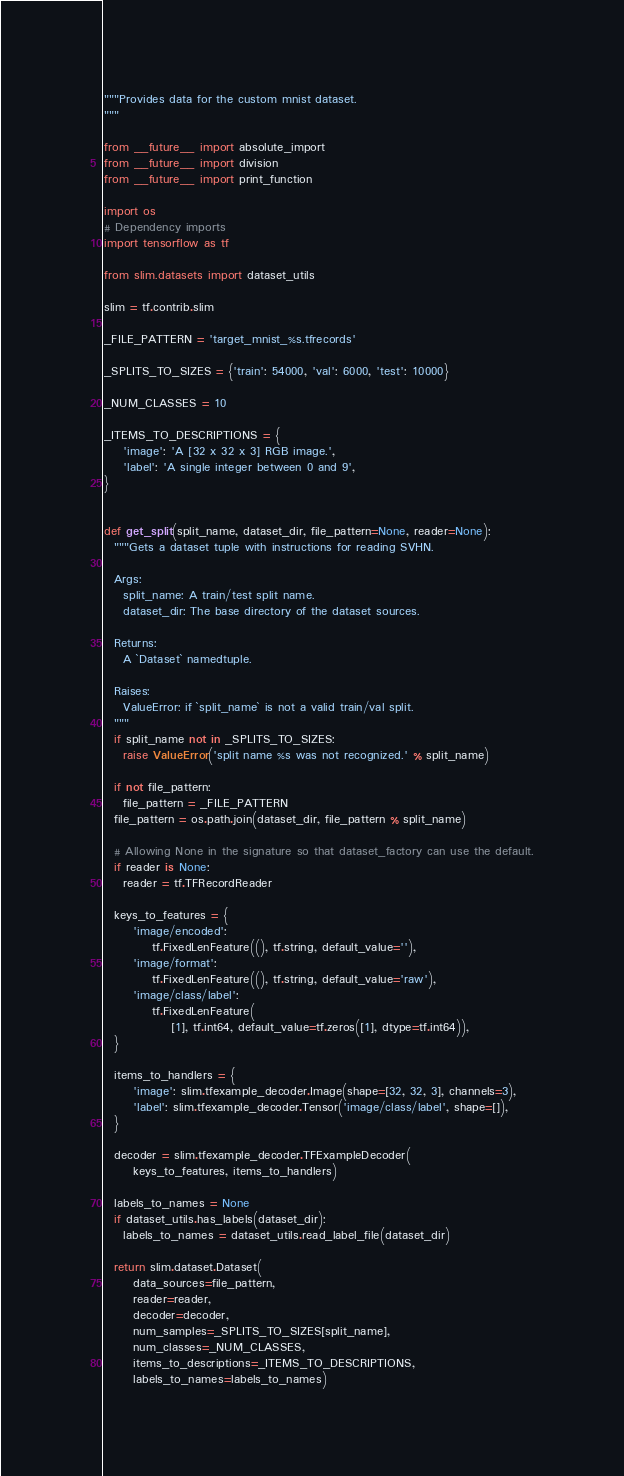Convert code to text. <code><loc_0><loc_0><loc_500><loc_500><_Python_>"""Provides data for the custom mnist dataset.
"""

from __future__ import absolute_import
from __future__ import division
from __future__ import print_function

import os
# Dependency imports
import tensorflow as tf

from slim.datasets import dataset_utils

slim = tf.contrib.slim

_FILE_PATTERN = 'target_mnist_%s.tfrecords'

_SPLITS_TO_SIZES = {'train': 54000, 'val': 6000, 'test': 10000}

_NUM_CLASSES = 10

_ITEMS_TO_DESCRIPTIONS = {
    'image': 'A [32 x 32 x 3] RGB image.',
    'label': 'A single integer between 0 and 9',
}


def get_split(split_name, dataset_dir, file_pattern=None, reader=None):
  """Gets a dataset tuple with instructions for reading SVHN.

  Args:
    split_name: A train/test split name.
    dataset_dir: The base directory of the dataset sources.

  Returns:
    A `Dataset` namedtuple.

  Raises:
    ValueError: if `split_name` is not a valid train/val split.
  """
  if split_name not in _SPLITS_TO_SIZES:
    raise ValueError('split name %s was not recognized.' % split_name)

  if not file_pattern:
    file_pattern = _FILE_PATTERN
  file_pattern = os.path.join(dataset_dir, file_pattern % split_name)

  # Allowing None in the signature so that dataset_factory can use the default.
  if reader is None:
    reader = tf.TFRecordReader

  keys_to_features = {
      'image/encoded':
          tf.FixedLenFeature((), tf.string, default_value=''),
      'image/format':
          tf.FixedLenFeature((), tf.string, default_value='raw'),
      'image/class/label':
          tf.FixedLenFeature(
              [1], tf.int64, default_value=tf.zeros([1], dtype=tf.int64)),
  }

  items_to_handlers = {
      'image': slim.tfexample_decoder.Image(shape=[32, 32, 3], channels=3),
      'label': slim.tfexample_decoder.Tensor('image/class/label', shape=[]),
  }

  decoder = slim.tfexample_decoder.TFExampleDecoder(
      keys_to_features, items_to_handlers)

  labels_to_names = None
  if dataset_utils.has_labels(dataset_dir):
    labels_to_names = dataset_utils.read_label_file(dataset_dir)

  return slim.dataset.Dataset(
      data_sources=file_pattern,
      reader=reader,
      decoder=decoder,
      num_samples=_SPLITS_TO_SIZES[split_name],
      num_classes=_NUM_CLASSES,
      items_to_descriptions=_ITEMS_TO_DESCRIPTIONS,
      labels_to_names=labels_to_names)
</code> 